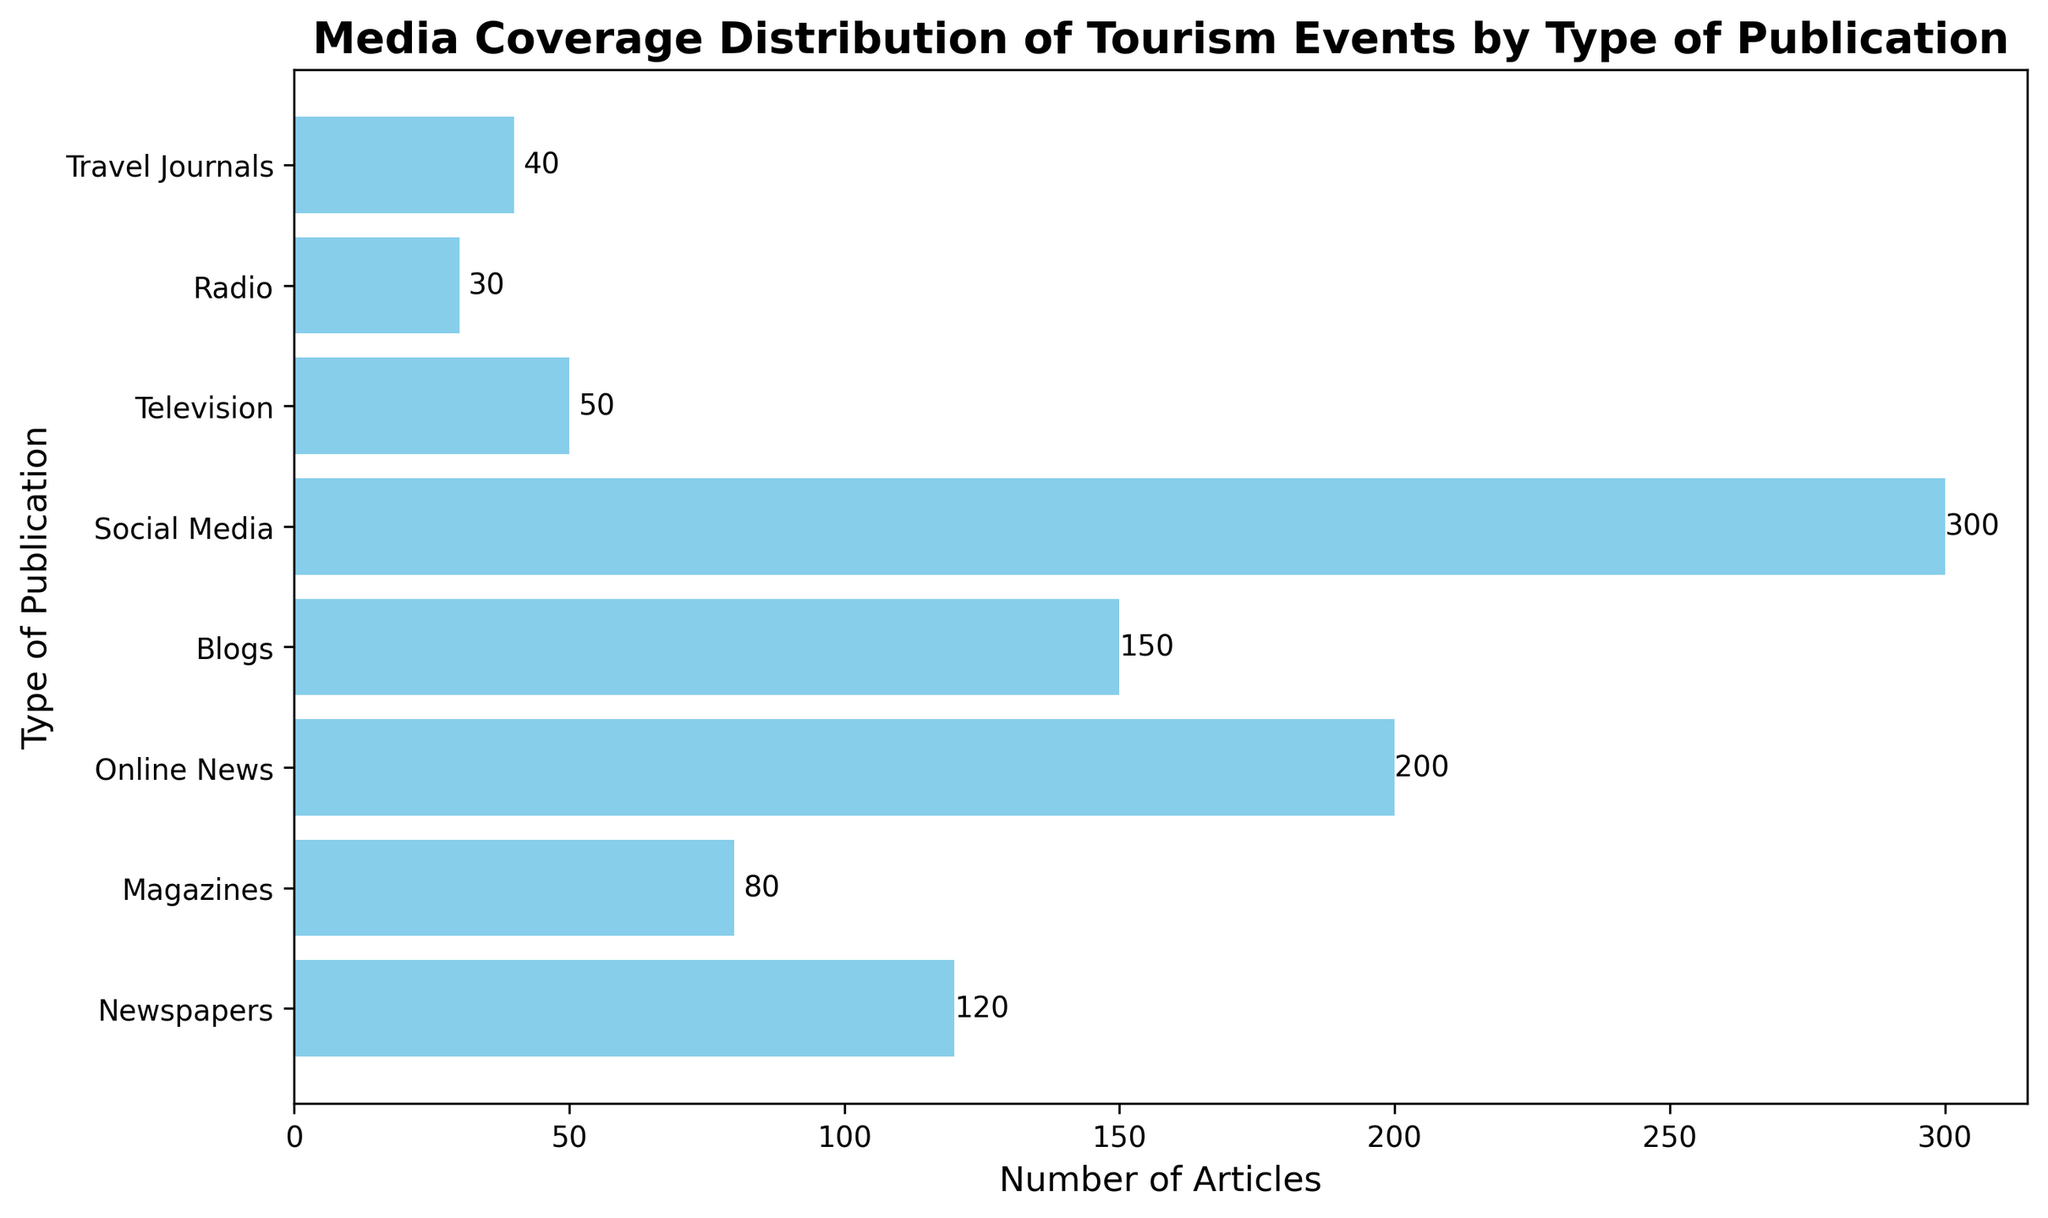What type of publication has the highest number of articles based on the chart? The bar corresponding to Social Media is the longest, indicating it has the highest number of articles. It shows a label of "300" confirming this.
Answer: Social Media Which type of publication has the lowest number of articles? The bar corresponding to Radio is the shortest, indicating it has the fewest articles. It shows a label of "30" confirming this.
Answer: Radio How many more articles are there in Online News compared to Travel Journals? Online News has 200 articles and Travel Journals have 40. Subtract the number of articles in Travel Journals from Online News: 200 - 40 = 160.
Answer: 160 What is the total number of articles covered by Newspapers, Magazines, and Television? Sum the number of articles in Newspapers, Magazines, and Television: 120 (Newspapers) + 80 (Magazines) + 50 (Television) = 250.
Answer: 250 How does the number of articles in Blogs compare to those in Newspapers and Magazines combined? Newspapers and Magazines combined have 120 + 80 = 200 articles. Blogs have 150 articles. Since 200 (Newspapers + Magazines) is greater than 150 (Blogs), Newspapers and Magazines combined have more articles than Blogs.
Answer: Newspapers and Magazines combined have more articles Which type(s) of publications have fewer than 50 articles? The bars for Television (50), Radio (30), and Travel Journals (40) are the shortest. Since we look for fewer than 50, Radio and Travel Journals qualify.
Answer: Radio and Travel Journals What is the average number of articles for all types of publications? Sum all the articles: 120 + 80 + 200 + 150 + 300 + 50 + 30 + 40 = 970. Divide by the number of publication types: 970 / 8 = 121.25.
Answer: 121.25 By how much does Social Media exceed the average number of articles? The average number of articles is 121.25. Social Media has 300 articles. Subtract the average from Social Media: 300 - 121.25 = 178.75.
Answer: 178.75 